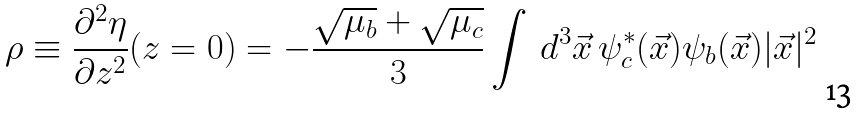Convert formula to latex. <formula><loc_0><loc_0><loc_500><loc_500>\rho \equiv \frac { \partial ^ { 2 } \eta } { \partial z ^ { 2 } } ( z = 0 ) = - \frac { \sqrt { \mu _ { b } } + \sqrt { \mu _ { c } } } { 3 } \int \, d ^ { 3 } \vec { x } \, \psi ^ { * } _ { c } ( \vec { x } ) \psi _ { b } ( \vec { x } ) | \vec { x } | ^ { 2 }</formula> 